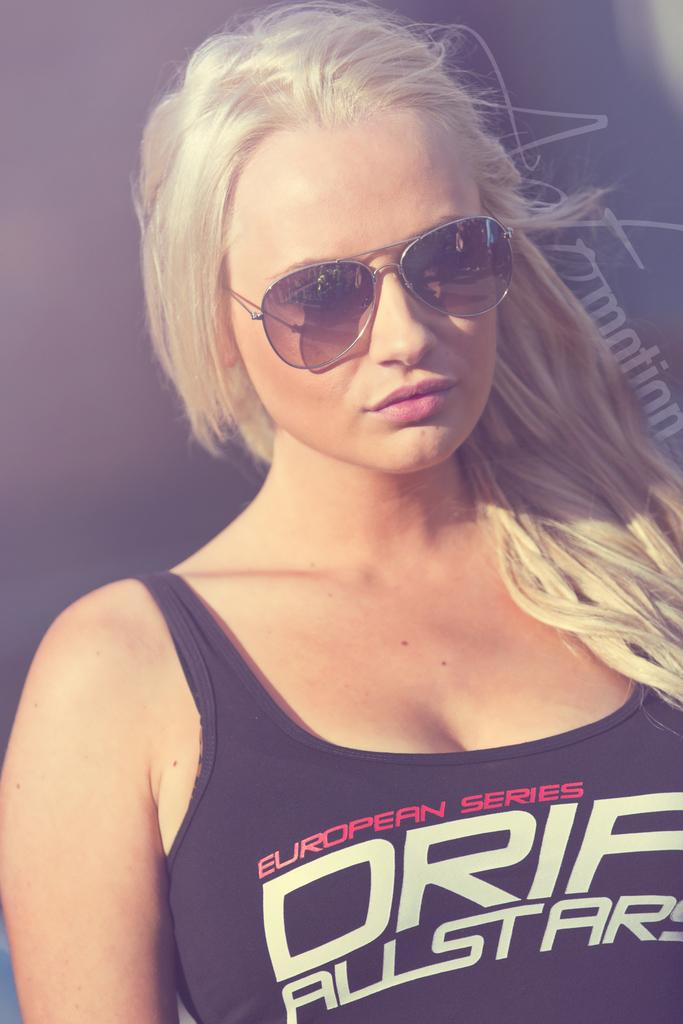Who is the main subject in the image? There is a lady in the image. What is the lady wearing on her face? The lady is wearing sunglasses. What color is the lady's t-shirt? The lady is wearing a black t-shirt. How many chins does the lady have in the image? The number of chins cannot be determined from the image, as it only shows the lady's face from a distance. 